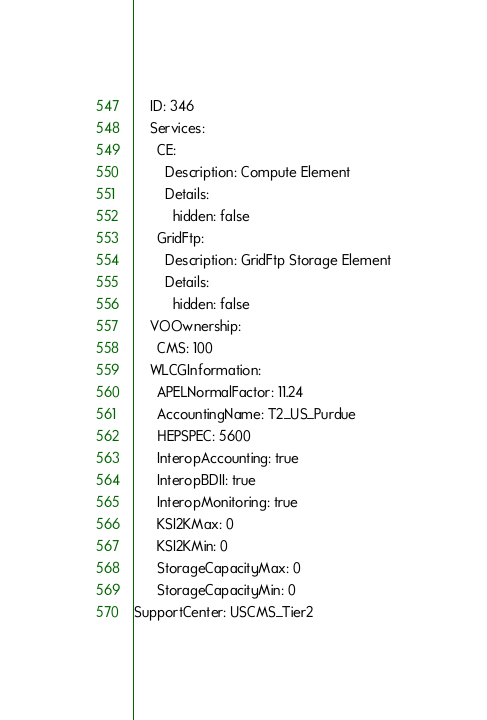<code> <loc_0><loc_0><loc_500><loc_500><_YAML_>    ID: 346
    Services:
      CE:
        Description: Compute Element
        Details:
          hidden: false
      GridFtp:
        Description: GridFtp Storage Element
        Details:
          hidden: false
    VOOwnership:
      CMS: 100
    WLCGInformation:
      APELNormalFactor: 11.24
      AccountingName: T2_US_Purdue
      HEPSPEC: 5600
      InteropAccounting: true
      InteropBDII: true
      InteropMonitoring: true
      KSI2KMax: 0
      KSI2KMin: 0
      StorageCapacityMax: 0
      StorageCapacityMin: 0
SupportCenter: USCMS_Tier2
</code> 